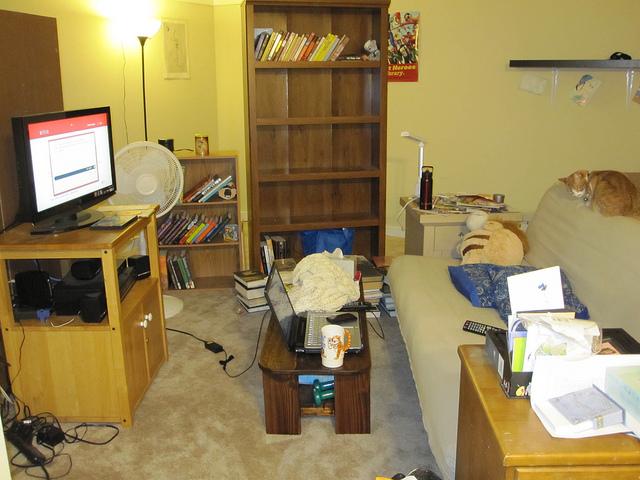Is the tv on?
Give a very brief answer. Yes. Is this room organized?
Quick response, please. No. What room is this?
Keep it brief. Living room. 